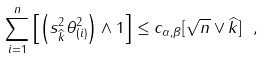<formula> <loc_0><loc_0><loc_500><loc_500>\sum _ { i = 1 } ^ { n } \left [ \left ( s ^ { 2 } _ { \widehat { k } } \theta ^ { 2 } _ { ( i ) } \right ) \wedge 1 \right ] \leq c _ { \alpha , \beta } [ \sqrt { n } \vee \widehat { k } ] \ ,</formula> 